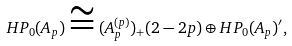Convert formula to latex. <formula><loc_0><loc_0><loc_500><loc_500>H P _ { 0 } ( A _ { p } ) \cong ( A _ { p } ^ { ( p ) } ) _ { + } ( 2 - 2 p ) \oplus H P _ { 0 } ( A _ { p } ) ^ { \prime } ,</formula> 